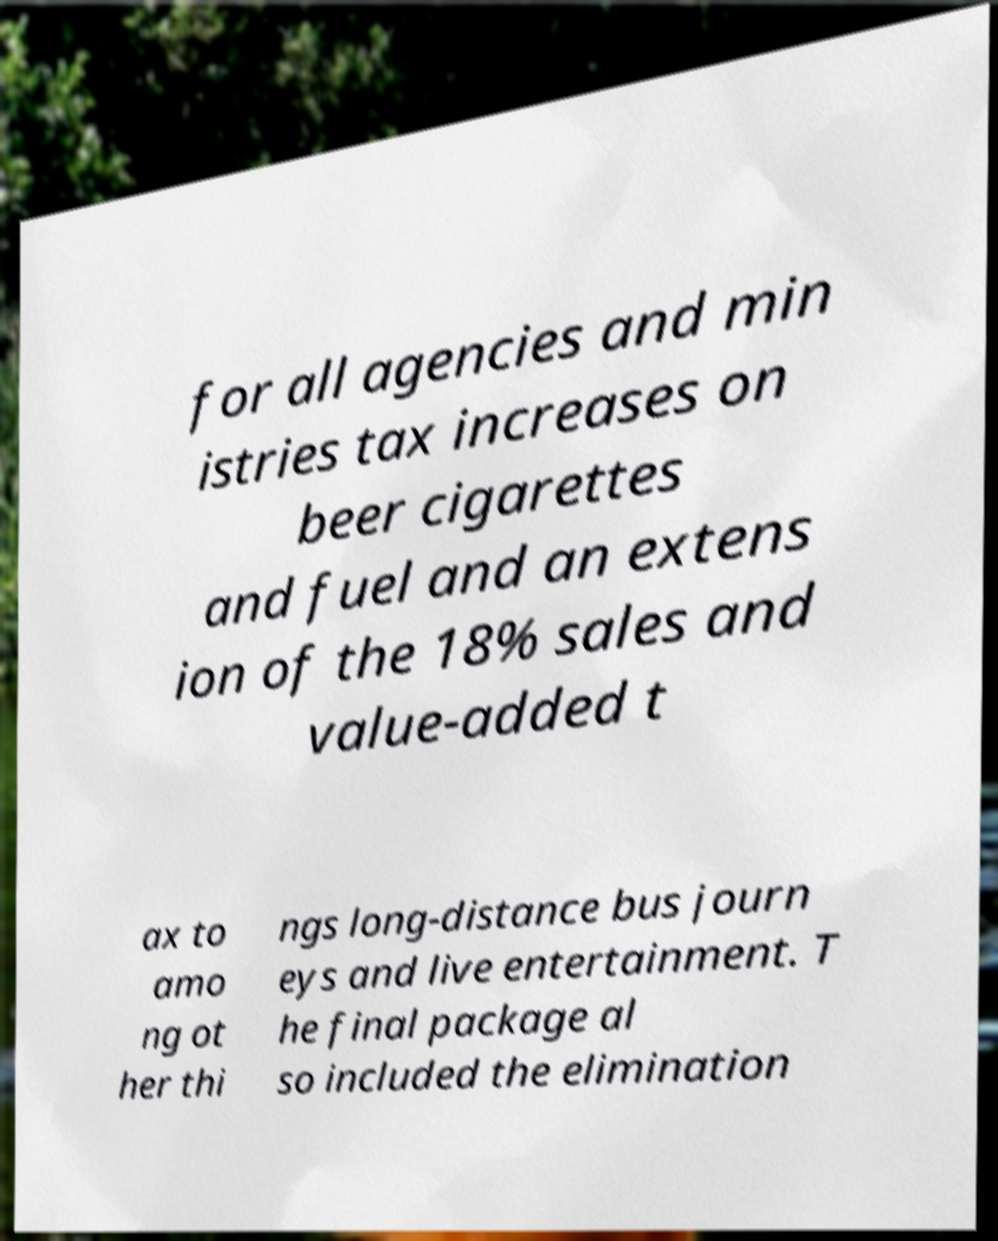I need the written content from this picture converted into text. Can you do that? for all agencies and min istries tax increases on beer cigarettes and fuel and an extens ion of the 18% sales and value-added t ax to amo ng ot her thi ngs long-distance bus journ eys and live entertainment. T he final package al so included the elimination 